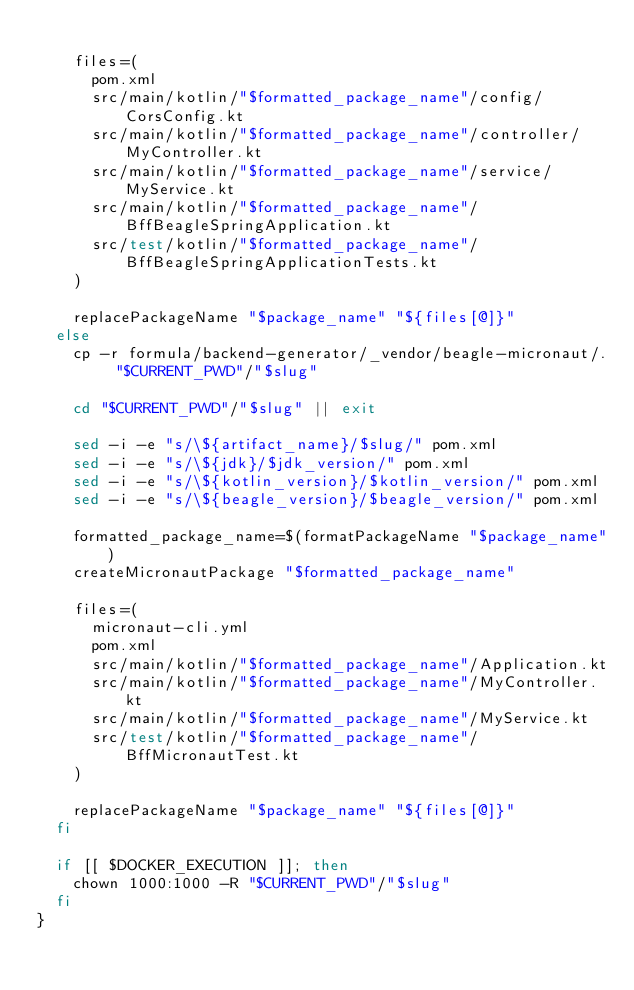<code> <loc_0><loc_0><loc_500><loc_500><_Bash_>
    files=(
      pom.xml
      src/main/kotlin/"$formatted_package_name"/config/CorsConfig.kt
      src/main/kotlin/"$formatted_package_name"/controller/MyController.kt
      src/main/kotlin/"$formatted_package_name"/service/MyService.kt
      src/main/kotlin/"$formatted_package_name"/BffBeagleSpringApplication.kt
      src/test/kotlin/"$formatted_package_name"/BffBeagleSpringApplicationTests.kt
    )

    replacePackageName "$package_name" "${files[@]}"
  else
    cp -r formula/backend-generator/_vendor/beagle-micronaut/. "$CURRENT_PWD"/"$slug"

    cd "$CURRENT_PWD"/"$slug" || exit

    sed -i -e "s/\${artifact_name}/$slug/" pom.xml
    sed -i -e "s/\${jdk}/$jdk_version/" pom.xml
    sed -i -e "s/\${kotlin_version}/$kotlin_version/" pom.xml
    sed -i -e "s/\${beagle_version}/$beagle_version/" pom.xml

    formatted_package_name=$(formatPackageName "$package_name")
    createMicronautPackage "$formatted_package_name"

    files=(
      micronaut-cli.yml
      pom.xml
      src/main/kotlin/"$formatted_package_name"/Application.kt
      src/main/kotlin/"$formatted_package_name"/MyController.kt
      src/main/kotlin/"$formatted_package_name"/MyService.kt
      src/test/kotlin/"$formatted_package_name"/BffMicronautTest.kt
    )

    replacePackageName "$package_name" "${files[@]}"
  fi

  if [[ $DOCKER_EXECUTION ]]; then
    chown 1000:1000 -R "$CURRENT_PWD"/"$slug"
  fi
}
</code> 